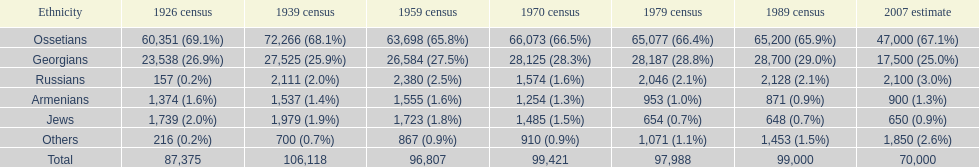What is the most prominent ethnicity? Ossetians. 